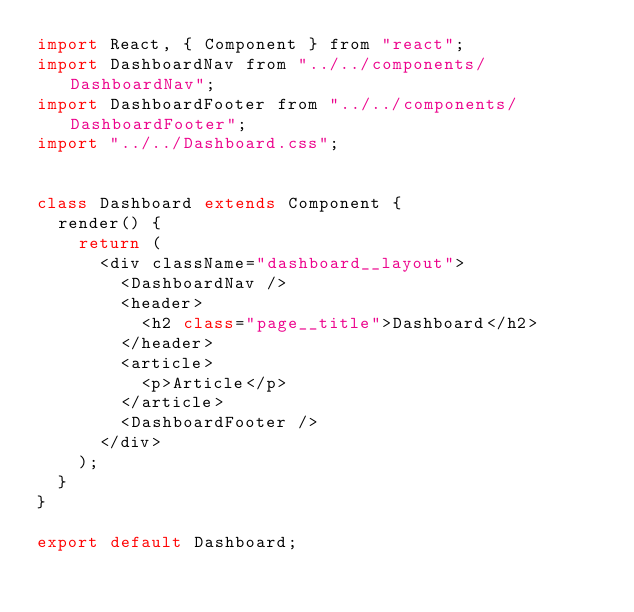Convert code to text. <code><loc_0><loc_0><loc_500><loc_500><_JavaScript_>import React, { Component } from "react";
import DashboardNav from "../../components/DashboardNav";
import DashboardFooter from "../../components/DashboardFooter";
import "../../Dashboard.css";


class Dashboard extends Component {
  render() {
    return (
      <div className="dashboard__layout">
        <DashboardNav />
        <header>
          <h2 class="page__title">Dashboard</h2>
        </header>
        <article>
          <p>Article</p>
        </article>
        <DashboardFooter />
      </div>
    );
  }
}

export default Dashboard;
</code> 